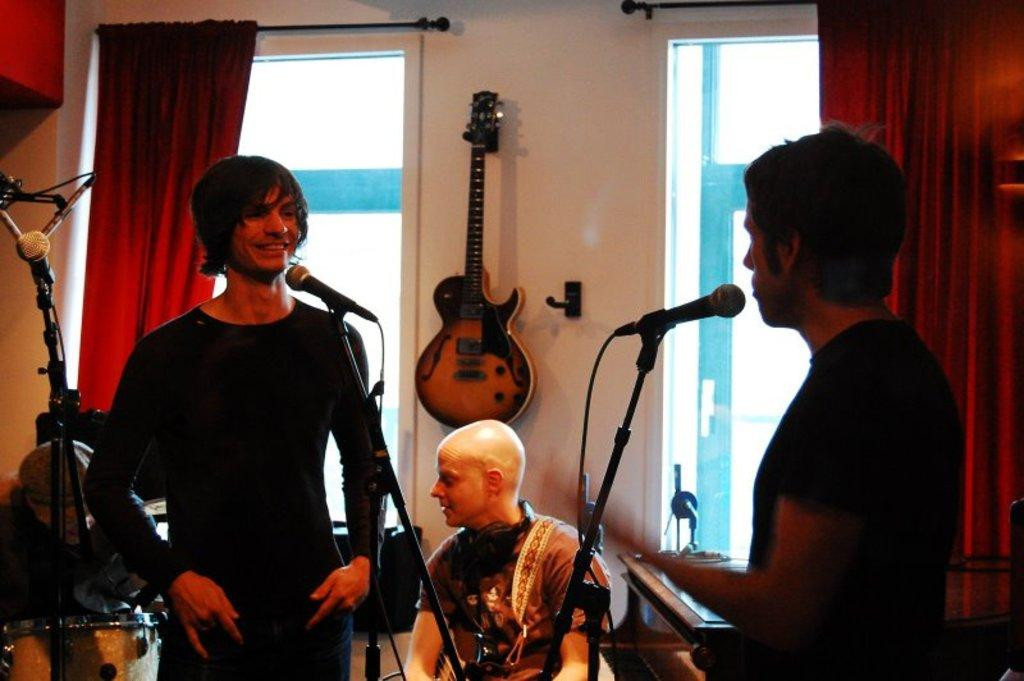What are the two persons in the image doing? The two persons are standing in front of a microphone. Is there anyone else in the image besides the two standing persons? Yes, there is one person sitting in the image. What can be seen hanging on the wall in the image? There is a guitar hanging on the wall. What type of bucket can be seen at the top of the hill in the image? There is no bucket or hill present in the image. What view can be seen from the hill in the image? There is no hill or view present in the image. 